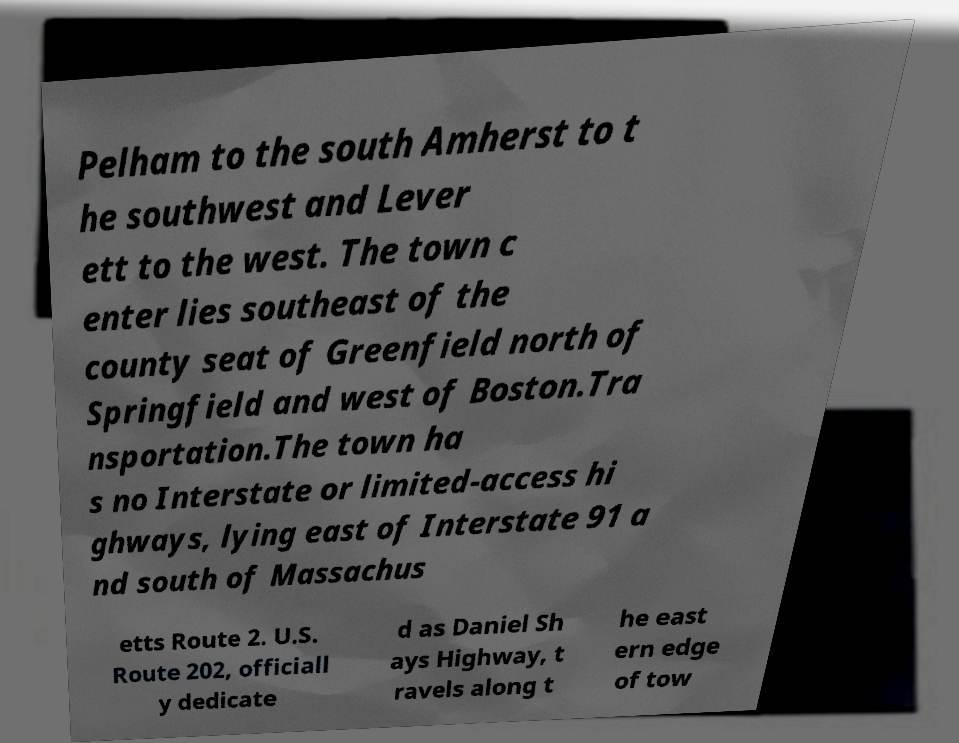Could you extract and type out the text from this image? Pelham to the south Amherst to t he southwest and Lever ett to the west. The town c enter lies southeast of the county seat of Greenfield north of Springfield and west of Boston.Tra nsportation.The town ha s no Interstate or limited-access hi ghways, lying east of Interstate 91 a nd south of Massachus etts Route 2. U.S. Route 202, officiall y dedicate d as Daniel Sh ays Highway, t ravels along t he east ern edge of tow 